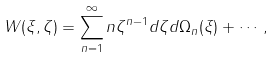<formula> <loc_0><loc_0><loc_500><loc_500>W ( \xi , \zeta ) = \sum _ { n = 1 } ^ { \infty } n \zeta ^ { n - 1 } d \zeta d \Omega _ { n } ( \xi ) + \cdots ,</formula> 